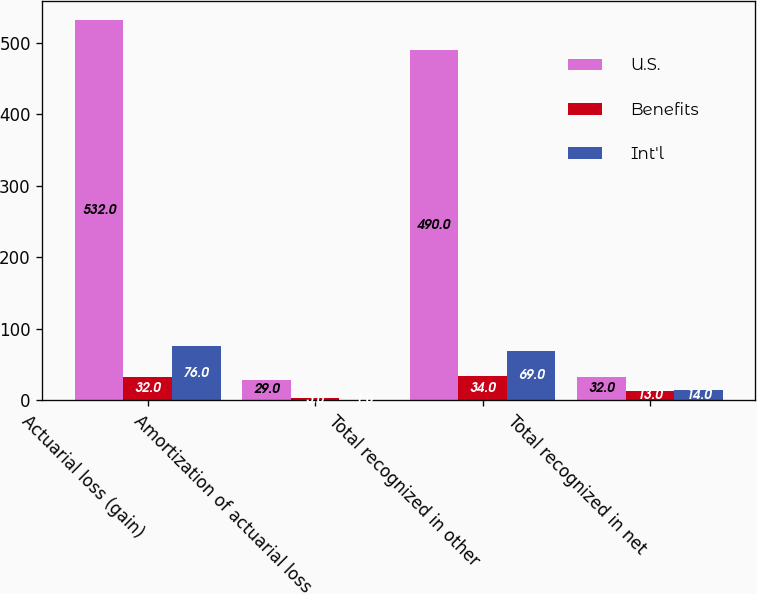Convert chart. <chart><loc_0><loc_0><loc_500><loc_500><stacked_bar_chart><ecel><fcel>Actuarial loss (gain)<fcel>Amortization of actuarial loss<fcel>Total recognized in other<fcel>Total recognized in net<nl><fcel>U.S.<fcel>532<fcel>29<fcel>490<fcel>32<nl><fcel>Benefits<fcel>32<fcel>3<fcel>34<fcel>13<nl><fcel>Int'l<fcel>76<fcel>1<fcel>69<fcel>14<nl></chart> 